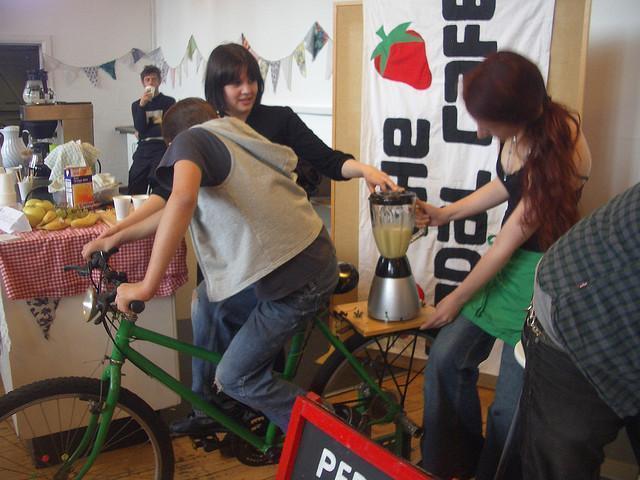How many people are there?
Give a very brief answer. 5. How many tracks have a train on them?
Give a very brief answer. 0. 